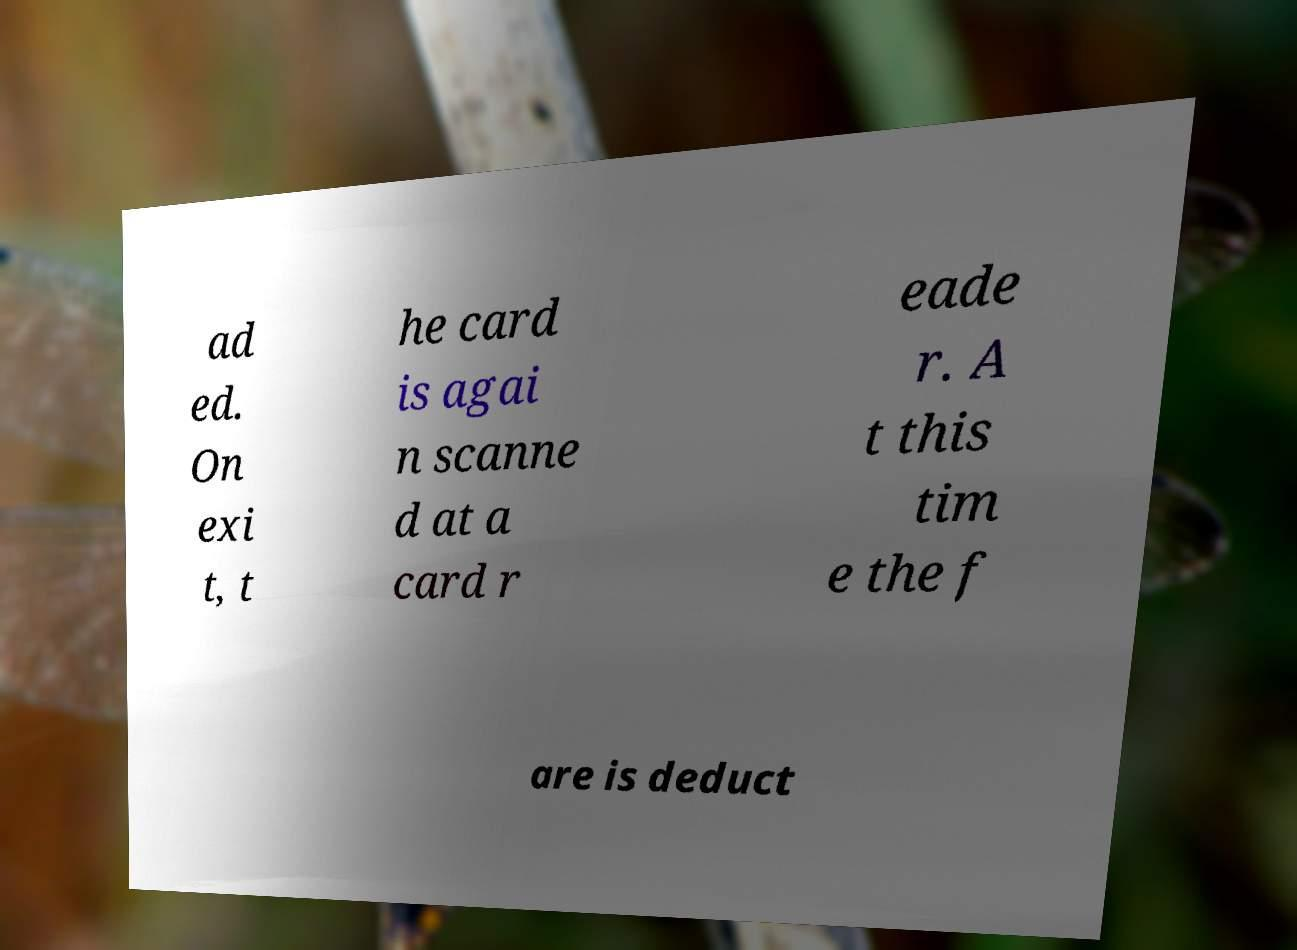For documentation purposes, I need the text within this image transcribed. Could you provide that? ad ed. On exi t, t he card is agai n scanne d at a card r eade r. A t this tim e the f are is deduct 